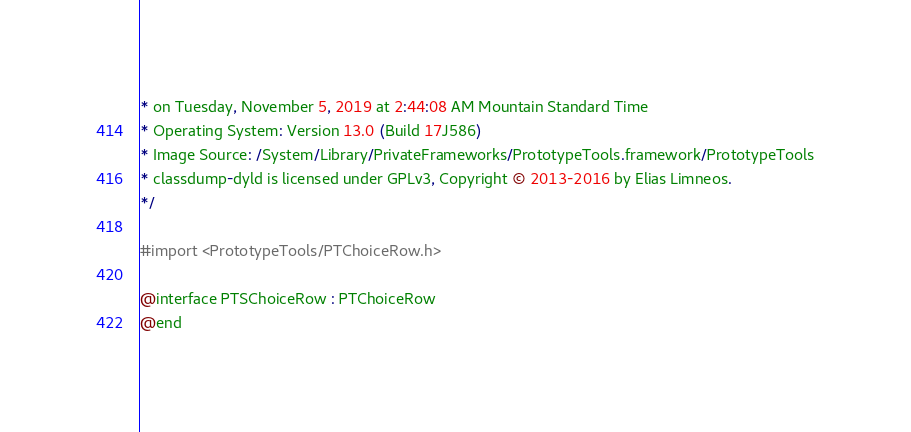<code> <loc_0><loc_0><loc_500><loc_500><_C_>* on Tuesday, November 5, 2019 at 2:44:08 AM Mountain Standard Time
* Operating System: Version 13.0 (Build 17J586)
* Image Source: /System/Library/PrivateFrameworks/PrototypeTools.framework/PrototypeTools
* classdump-dyld is licensed under GPLv3, Copyright © 2013-2016 by Elias Limneos.
*/

#import <PrototypeTools/PTChoiceRow.h>

@interface PTSChoiceRow : PTChoiceRow
@end

</code> 